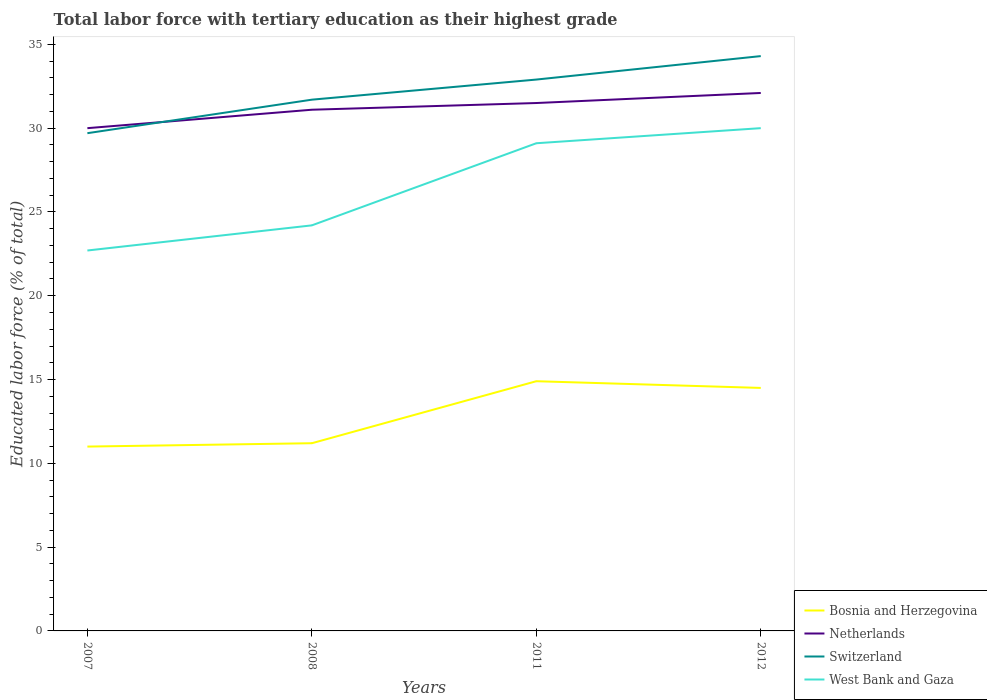How many different coloured lines are there?
Your response must be concise. 4. Does the line corresponding to Switzerland intersect with the line corresponding to Netherlands?
Your response must be concise. Yes. Is the number of lines equal to the number of legend labels?
Your answer should be compact. Yes. What is the total percentage of male labor force with tertiary education in West Bank and Gaza in the graph?
Provide a short and direct response. -0.9. What is the difference between the highest and the second highest percentage of male labor force with tertiary education in Switzerland?
Provide a short and direct response. 4.6. How many years are there in the graph?
Keep it short and to the point. 4. What is the difference between two consecutive major ticks on the Y-axis?
Your answer should be compact. 5. Are the values on the major ticks of Y-axis written in scientific E-notation?
Your answer should be very brief. No. Does the graph contain any zero values?
Provide a short and direct response. No. How many legend labels are there?
Ensure brevity in your answer.  4. What is the title of the graph?
Offer a very short reply. Total labor force with tertiary education as their highest grade. What is the label or title of the X-axis?
Offer a very short reply. Years. What is the label or title of the Y-axis?
Make the answer very short. Educated labor force (% of total). What is the Educated labor force (% of total) of Netherlands in 2007?
Offer a terse response. 30. What is the Educated labor force (% of total) of Switzerland in 2007?
Make the answer very short. 29.7. What is the Educated labor force (% of total) in West Bank and Gaza in 2007?
Offer a very short reply. 22.7. What is the Educated labor force (% of total) in Bosnia and Herzegovina in 2008?
Offer a terse response. 11.2. What is the Educated labor force (% of total) in Netherlands in 2008?
Your answer should be very brief. 31.1. What is the Educated labor force (% of total) of Switzerland in 2008?
Make the answer very short. 31.7. What is the Educated labor force (% of total) of West Bank and Gaza in 2008?
Your answer should be compact. 24.2. What is the Educated labor force (% of total) in Bosnia and Herzegovina in 2011?
Your answer should be compact. 14.9. What is the Educated labor force (% of total) in Netherlands in 2011?
Ensure brevity in your answer.  31.5. What is the Educated labor force (% of total) in Switzerland in 2011?
Offer a terse response. 32.9. What is the Educated labor force (% of total) of West Bank and Gaza in 2011?
Keep it short and to the point. 29.1. What is the Educated labor force (% of total) of Netherlands in 2012?
Provide a short and direct response. 32.1. What is the Educated labor force (% of total) in Switzerland in 2012?
Make the answer very short. 34.3. Across all years, what is the maximum Educated labor force (% of total) of Bosnia and Herzegovina?
Give a very brief answer. 14.9. Across all years, what is the maximum Educated labor force (% of total) in Netherlands?
Offer a terse response. 32.1. Across all years, what is the maximum Educated labor force (% of total) in Switzerland?
Ensure brevity in your answer.  34.3. Across all years, what is the minimum Educated labor force (% of total) in Bosnia and Herzegovina?
Your answer should be very brief. 11. Across all years, what is the minimum Educated labor force (% of total) in Netherlands?
Your response must be concise. 30. Across all years, what is the minimum Educated labor force (% of total) of Switzerland?
Provide a short and direct response. 29.7. Across all years, what is the minimum Educated labor force (% of total) of West Bank and Gaza?
Offer a very short reply. 22.7. What is the total Educated labor force (% of total) of Bosnia and Herzegovina in the graph?
Your response must be concise. 51.6. What is the total Educated labor force (% of total) of Netherlands in the graph?
Make the answer very short. 124.7. What is the total Educated labor force (% of total) of Switzerland in the graph?
Provide a succinct answer. 128.6. What is the total Educated labor force (% of total) of West Bank and Gaza in the graph?
Offer a very short reply. 106. What is the difference between the Educated labor force (% of total) in Netherlands in 2007 and that in 2008?
Your response must be concise. -1.1. What is the difference between the Educated labor force (% of total) of Switzerland in 2007 and that in 2008?
Ensure brevity in your answer.  -2. What is the difference between the Educated labor force (% of total) of West Bank and Gaza in 2007 and that in 2008?
Ensure brevity in your answer.  -1.5. What is the difference between the Educated labor force (% of total) in West Bank and Gaza in 2007 and that in 2011?
Your answer should be very brief. -6.4. What is the difference between the Educated labor force (% of total) in Bosnia and Herzegovina in 2007 and that in 2012?
Give a very brief answer. -3.5. What is the difference between the Educated labor force (% of total) in Switzerland in 2007 and that in 2012?
Your response must be concise. -4.6. What is the difference between the Educated labor force (% of total) in West Bank and Gaza in 2008 and that in 2012?
Make the answer very short. -5.8. What is the difference between the Educated labor force (% of total) of Netherlands in 2011 and that in 2012?
Keep it short and to the point. -0.6. What is the difference between the Educated labor force (% of total) in Bosnia and Herzegovina in 2007 and the Educated labor force (% of total) in Netherlands in 2008?
Give a very brief answer. -20.1. What is the difference between the Educated labor force (% of total) of Bosnia and Herzegovina in 2007 and the Educated labor force (% of total) of Switzerland in 2008?
Make the answer very short. -20.7. What is the difference between the Educated labor force (% of total) of Bosnia and Herzegovina in 2007 and the Educated labor force (% of total) of West Bank and Gaza in 2008?
Offer a very short reply. -13.2. What is the difference between the Educated labor force (% of total) of Netherlands in 2007 and the Educated labor force (% of total) of Switzerland in 2008?
Provide a short and direct response. -1.7. What is the difference between the Educated labor force (% of total) in Netherlands in 2007 and the Educated labor force (% of total) in West Bank and Gaza in 2008?
Your answer should be compact. 5.8. What is the difference between the Educated labor force (% of total) in Switzerland in 2007 and the Educated labor force (% of total) in West Bank and Gaza in 2008?
Provide a short and direct response. 5.5. What is the difference between the Educated labor force (% of total) of Bosnia and Herzegovina in 2007 and the Educated labor force (% of total) of Netherlands in 2011?
Your answer should be very brief. -20.5. What is the difference between the Educated labor force (% of total) of Bosnia and Herzegovina in 2007 and the Educated labor force (% of total) of Switzerland in 2011?
Provide a succinct answer. -21.9. What is the difference between the Educated labor force (% of total) of Bosnia and Herzegovina in 2007 and the Educated labor force (% of total) of West Bank and Gaza in 2011?
Offer a very short reply. -18.1. What is the difference between the Educated labor force (% of total) in Netherlands in 2007 and the Educated labor force (% of total) in Switzerland in 2011?
Your response must be concise. -2.9. What is the difference between the Educated labor force (% of total) in Switzerland in 2007 and the Educated labor force (% of total) in West Bank and Gaza in 2011?
Make the answer very short. 0.6. What is the difference between the Educated labor force (% of total) of Bosnia and Herzegovina in 2007 and the Educated labor force (% of total) of Netherlands in 2012?
Offer a very short reply. -21.1. What is the difference between the Educated labor force (% of total) in Bosnia and Herzegovina in 2007 and the Educated labor force (% of total) in Switzerland in 2012?
Provide a succinct answer. -23.3. What is the difference between the Educated labor force (% of total) of Bosnia and Herzegovina in 2008 and the Educated labor force (% of total) of Netherlands in 2011?
Offer a very short reply. -20.3. What is the difference between the Educated labor force (% of total) of Bosnia and Herzegovina in 2008 and the Educated labor force (% of total) of Switzerland in 2011?
Give a very brief answer. -21.7. What is the difference between the Educated labor force (% of total) of Bosnia and Herzegovina in 2008 and the Educated labor force (% of total) of West Bank and Gaza in 2011?
Keep it short and to the point. -17.9. What is the difference between the Educated labor force (% of total) of Netherlands in 2008 and the Educated labor force (% of total) of West Bank and Gaza in 2011?
Provide a short and direct response. 2. What is the difference between the Educated labor force (% of total) in Bosnia and Herzegovina in 2008 and the Educated labor force (% of total) in Netherlands in 2012?
Offer a terse response. -20.9. What is the difference between the Educated labor force (% of total) in Bosnia and Herzegovina in 2008 and the Educated labor force (% of total) in Switzerland in 2012?
Your response must be concise. -23.1. What is the difference between the Educated labor force (% of total) of Bosnia and Herzegovina in 2008 and the Educated labor force (% of total) of West Bank and Gaza in 2012?
Make the answer very short. -18.8. What is the difference between the Educated labor force (% of total) in Netherlands in 2008 and the Educated labor force (% of total) in Switzerland in 2012?
Make the answer very short. -3.2. What is the difference between the Educated labor force (% of total) in Bosnia and Herzegovina in 2011 and the Educated labor force (% of total) in Netherlands in 2012?
Provide a succinct answer. -17.2. What is the difference between the Educated labor force (% of total) of Bosnia and Herzegovina in 2011 and the Educated labor force (% of total) of Switzerland in 2012?
Offer a very short reply. -19.4. What is the difference between the Educated labor force (% of total) in Bosnia and Herzegovina in 2011 and the Educated labor force (% of total) in West Bank and Gaza in 2012?
Your answer should be very brief. -15.1. What is the difference between the Educated labor force (% of total) in Netherlands in 2011 and the Educated labor force (% of total) in Switzerland in 2012?
Offer a very short reply. -2.8. What is the average Educated labor force (% of total) in Netherlands per year?
Provide a succinct answer. 31.18. What is the average Educated labor force (% of total) of Switzerland per year?
Give a very brief answer. 32.15. What is the average Educated labor force (% of total) in West Bank and Gaza per year?
Keep it short and to the point. 26.5. In the year 2007, what is the difference between the Educated labor force (% of total) in Bosnia and Herzegovina and Educated labor force (% of total) in Netherlands?
Your answer should be compact. -19. In the year 2007, what is the difference between the Educated labor force (% of total) of Bosnia and Herzegovina and Educated labor force (% of total) of Switzerland?
Ensure brevity in your answer.  -18.7. In the year 2007, what is the difference between the Educated labor force (% of total) of Bosnia and Herzegovina and Educated labor force (% of total) of West Bank and Gaza?
Provide a succinct answer. -11.7. In the year 2007, what is the difference between the Educated labor force (% of total) in Switzerland and Educated labor force (% of total) in West Bank and Gaza?
Provide a succinct answer. 7. In the year 2008, what is the difference between the Educated labor force (% of total) of Bosnia and Herzegovina and Educated labor force (% of total) of Netherlands?
Provide a succinct answer. -19.9. In the year 2008, what is the difference between the Educated labor force (% of total) of Bosnia and Herzegovina and Educated labor force (% of total) of Switzerland?
Your response must be concise. -20.5. In the year 2008, what is the difference between the Educated labor force (% of total) in Bosnia and Herzegovina and Educated labor force (% of total) in West Bank and Gaza?
Provide a succinct answer. -13. In the year 2008, what is the difference between the Educated labor force (% of total) in Netherlands and Educated labor force (% of total) in Switzerland?
Offer a terse response. -0.6. In the year 2008, what is the difference between the Educated labor force (% of total) of Netherlands and Educated labor force (% of total) of West Bank and Gaza?
Your answer should be compact. 6.9. In the year 2011, what is the difference between the Educated labor force (% of total) in Bosnia and Herzegovina and Educated labor force (% of total) in Netherlands?
Your answer should be very brief. -16.6. In the year 2011, what is the difference between the Educated labor force (% of total) in Bosnia and Herzegovina and Educated labor force (% of total) in Switzerland?
Make the answer very short. -18. In the year 2011, what is the difference between the Educated labor force (% of total) in Netherlands and Educated labor force (% of total) in Switzerland?
Ensure brevity in your answer.  -1.4. In the year 2011, what is the difference between the Educated labor force (% of total) of Switzerland and Educated labor force (% of total) of West Bank and Gaza?
Provide a short and direct response. 3.8. In the year 2012, what is the difference between the Educated labor force (% of total) in Bosnia and Herzegovina and Educated labor force (% of total) in Netherlands?
Your response must be concise. -17.6. In the year 2012, what is the difference between the Educated labor force (% of total) of Bosnia and Herzegovina and Educated labor force (% of total) of Switzerland?
Ensure brevity in your answer.  -19.8. In the year 2012, what is the difference between the Educated labor force (% of total) in Bosnia and Herzegovina and Educated labor force (% of total) in West Bank and Gaza?
Ensure brevity in your answer.  -15.5. In the year 2012, what is the difference between the Educated labor force (% of total) of Netherlands and Educated labor force (% of total) of West Bank and Gaza?
Give a very brief answer. 2.1. In the year 2012, what is the difference between the Educated labor force (% of total) of Switzerland and Educated labor force (% of total) of West Bank and Gaza?
Your answer should be compact. 4.3. What is the ratio of the Educated labor force (% of total) in Bosnia and Herzegovina in 2007 to that in 2008?
Your response must be concise. 0.98. What is the ratio of the Educated labor force (% of total) of Netherlands in 2007 to that in 2008?
Your response must be concise. 0.96. What is the ratio of the Educated labor force (% of total) of Switzerland in 2007 to that in 2008?
Offer a very short reply. 0.94. What is the ratio of the Educated labor force (% of total) in West Bank and Gaza in 2007 to that in 2008?
Ensure brevity in your answer.  0.94. What is the ratio of the Educated labor force (% of total) of Bosnia and Herzegovina in 2007 to that in 2011?
Give a very brief answer. 0.74. What is the ratio of the Educated labor force (% of total) in Netherlands in 2007 to that in 2011?
Provide a short and direct response. 0.95. What is the ratio of the Educated labor force (% of total) of Switzerland in 2007 to that in 2011?
Provide a succinct answer. 0.9. What is the ratio of the Educated labor force (% of total) of West Bank and Gaza in 2007 to that in 2011?
Provide a short and direct response. 0.78. What is the ratio of the Educated labor force (% of total) in Bosnia and Herzegovina in 2007 to that in 2012?
Keep it short and to the point. 0.76. What is the ratio of the Educated labor force (% of total) of Netherlands in 2007 to that in 2012?
Your answer should be very brief. 0.93. What is the ratio of the Educated labor force (% of total) in Switzerland in 2007 to that in 2012?
Offer a very short reply. 0.87. What is the ratio of the Educated labor force (% of total) of West Bank and Gaza in 2007 to that in 2012?
Offer a terse response. 0.76. What is the ratio of the Educated labor force (% of total) in Bosnia and Herzegovina in 2008 to that in 2011?
Give a very brief answer. 0.75. What is the ratio of the Educated labor force (% of total) of Netherlands in 2008 to that in 2011?
Provide a short and direct response. 0.99. What is the ratio of the Educated labor force (% of total) in Switzerland in 2008 to that in 2011?
Offer a very short reply. 0.96. What is the ratio of the Educated labor force (% of total) in West Bank and Gaza in 2008 to that in 2011?
Make the answer very short. 0.83. What is the ratio of the Educated labor force (% of total) in Bosnia and Herzegovina in 2008 to that in 2012?
Give a very brief answer. 0.77. What is the ratio of the Educated labor force (% of total) in Netherlands in 2008 to that in 2012?
Keep it short and to the point. 0.97. What is the ratio of the Educated labor force (% of total) in Switzerland in 2008 to that in 2012?
Keep it short and to the point. 0.92. What is the ratio of the Educated labor force (% of total) of West Bank and Gaza in 2008 to that in 2012?
Make the answer very short. 0.81. What is the ratio of the Educated labor force (% of total) in Bosnia and Herzegovina in 2011 to that in 2012?
Your response must be concise. 1.03. What is the ratio of the Educated labor force (% of total) of Netherlands in 2011 to that in 2012?
Offer a terse response. 0.98. What is the ratio of the Educated labor force (% of total) of Switzerland in 2011 to that in 2012?
Keep it short and to the point. 0.96. What is the ratio of the Educated labor force (% of total) in West Bank and Gaza in 2011 to that in 2012?
Keep it short and to the point. 0.97. What is the difference between the highest and the second highest Educated labor force (% of total) of Bosnia and Herzegovina?
Provide a short and direct response. 0.4. What is the difference between the highest and the second highest Educated labor force (% of total) in Switzerland?
Offer a very short reply. 1.4. What is the difference between the highest and the lowest Educated labor force (% of total) in Netherlands?
Your answer should be very brief. 2.1. What is the difference between the highest and the lowest Educated labor force (% of total) in Switzerland?
Your answer should be compact. 4.6. What is the difference between the highest and the lowest Educated labor force (% of total) in West Bank and Gaza?
Ensure brevity in your answer.  7.3. 